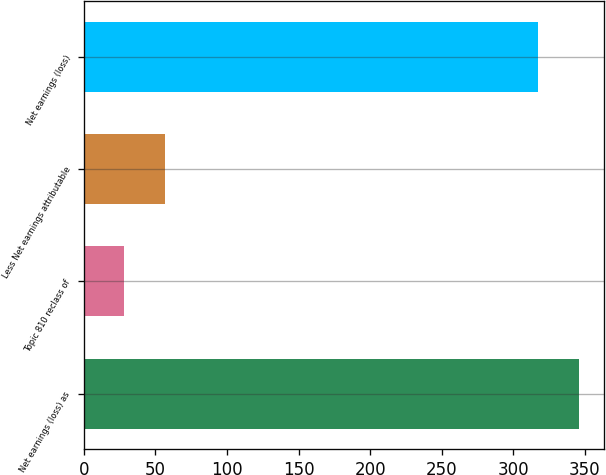Convert chart to OTSL. <chart><loc_0><loc_0><loc_500><loc_500><bar_chart><fcel>Net earnings (loss) as<fcel>Topic 810 reclass of<fcel>Less Net earnings attributable<fcel>Net earnings (loss)<nl><fcel>346.2<fcel>28<fcel>56.85<fcel>317.35<nl></chart> 